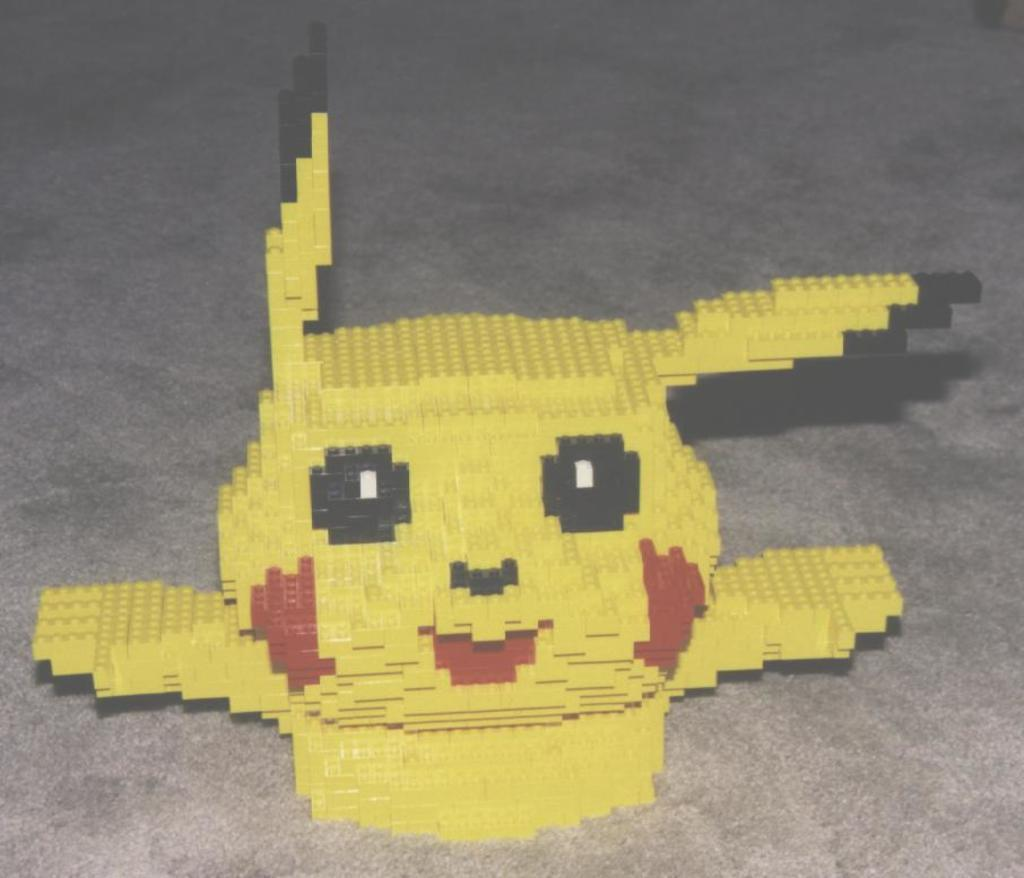What type of toy is in the image? There is a Lego in the image. What colors can be seen on the Lego? The Lego has yellow, red, black, and white colors. What is the surface on which the Lego is placed? The Lego is on an ash-colored surface. What type of gun is visible in the image? There is no gun present in the image; it features a Lego toy. How many people are in the group shown in the image? There is no group of people present in the image; it features a Lego toy on an ash-colored surface. 